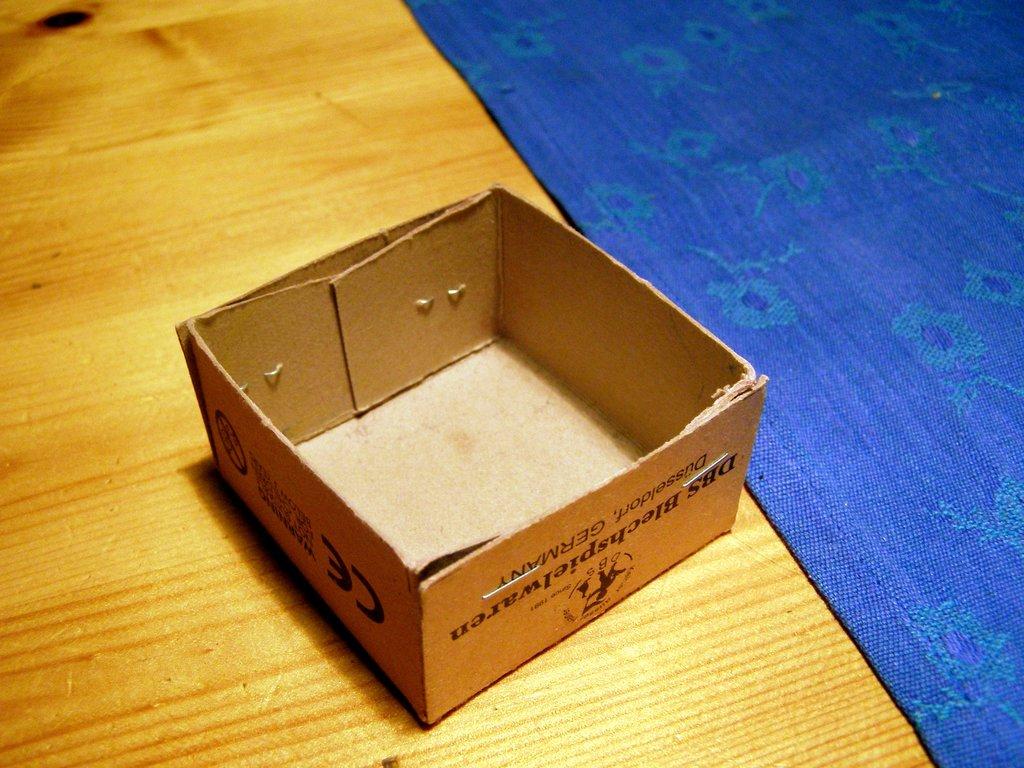Is there a ce on this box?
Provide a short and direct response. Yes. In what country was this box manufactured?
Your answer should be very brief. Germany. 